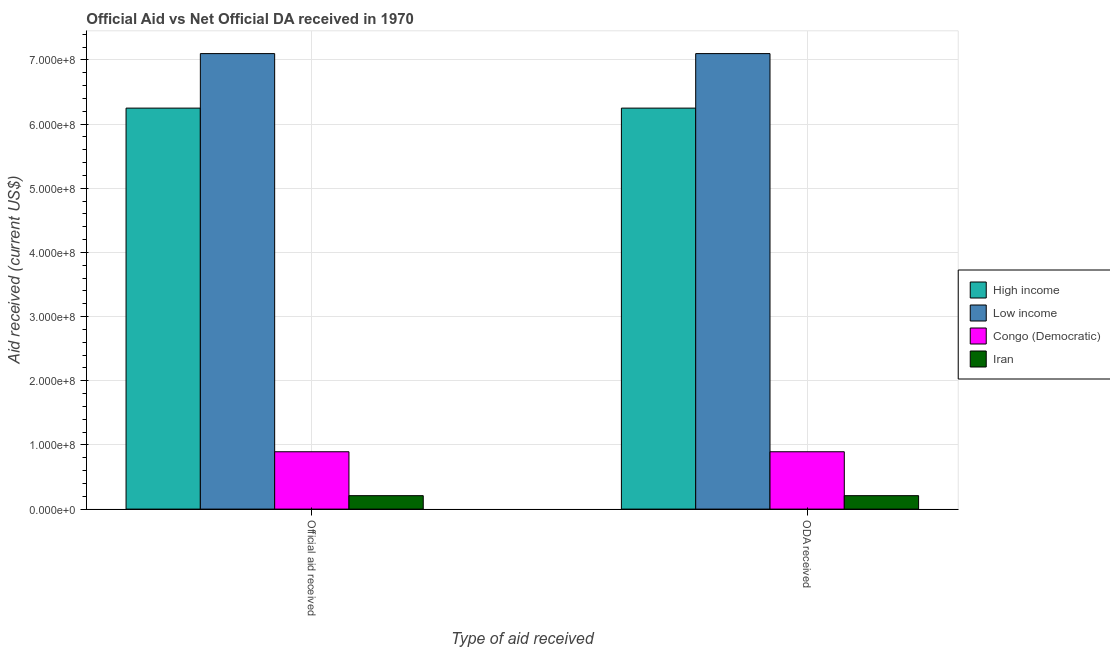How many groups of bars are there?
Keep it short and to the point. 2. How many bars are there on the 2nd tick from the left?
Give a very brief answer. 4. How many bars are there on the 1st tick from the right?
Provide a short and direct response. 4. What is the label of the 1st group of bars from the left?
Make the answer very short. Official aid received. What is the official aid received in Low income?
Make the answer very short. 7.10e+08. Across all countries, what is the maximum oda received?
Ensure brevity in your answer.  7.10e+08. Across all countries, what is the minimum oda received?
Give a very brief answer. 2.10e+07. In which country was the official aid received minimum?
Offer a very short reply. Iran. What is the total oda received in the graph?
Provide a short and direct response. 1.44e+09. What is the difference between the oda received in Iran and that in Low income?
Offer a very short reply. -6.89e+08. What is the difference between the official aid received in Congo (Democratic) and the oda received in Iran?
Your response must be concise. 6.84e+07. What is the average official aid received per country?
Provide a succinct answer. 3.61e+08. What is the difference between the oda received and official aid received in Low income?
Keep it short and to the point. 0. What is the ratio of the official aid received in Iran to that in High income?
Provide a short and direct response. 0.03. What does the 1st bar from the right in Official aid received represents?
Make the answer very short. Iran. Are the values on the major ticks of Y-axis written in scientific E-notation?
Offer a terse response. Yes. Where does the legend appear in the graph?
Offer a very short reply. Center right. How are the legend labels stacked?
Make the answer very short. Vertical. What is the title of the graph?
Give a very brief answer. Official Aid vs Net Official DA received in 1970 . Does "Macedonia" appear as one of the legend labels in the graph?
Ensure brevity in your answer.  No. What is the label or title of the X-axis?
Your answer should be compact. Type of aid received. What is the label or title of the Y-axis?
Offer a terse response. Aid received (current US$). What is the Aid received (current US$) of High income in Official aid received?
Ensure brevity in your answer.  6.25e+08. What is the Aid received (current US$) of Low income in Official aid received?
Your answer should be compact. 7.10e+08. What is the Aid received (current US$) in Congo (Democratic) in Official aid received?
Make the answer very short. 8.94e+07. What is the Aid received (current US$) of Iran in Official aid received?
Offer a very short reply. 2.10e+07. What is the Aid received (current US$) of High income in ODA received?
Offer a terse response. 6.25e+08. What is the Aid received (current US$) of Low income in ODA received?
Your answer should be compact. 7.10e+08. What is the Aid received (current US$) in Congo (Democratic) in ODA received?
Keep it short and to the point. 8.94e+07. What is the Aid received (current US$) in Iran in ODA received?
Ensure brevity in your answer.  2.10e+07. Across all Type of aid received, what is the maximum Aid received (current US$) of High income?
Provide a succinct answer. 6.25e+08. Across all Type of aid received, what is the maximum Aid received (current US$) of Low income?
Your answer should be very brief. 7.10e+08. Across all Type of aid received, what is the maximum Aid received (current US$) in Congo (Democratic)?
Offer a terse response. 8.94e+07. Across all Type of aid received, what is the maximum Aid received (current US$) of Iran?
Provide a succinct answer. 2.10e+07. Across all Type of aid received, what is the minimum Aid received (current US$) in High income?
Keep it short and to the point. 6.25e+08. Across all Type of aid received, what is the minimum Aid received (current US$) of Low income?
Keep it short and to the point. 7.10e+08. Across all Type of aid received, what is the minimum Aid received (current US$) in Congo (Democratic)?
Give a very brief answer. 8.94e+07. Across all Type of aid received, what is the minimum Aid received (current US$) in Iran?
Provide a short and direct response. 2.10e+07. What is the total Aid received (current US$) of High income in the graph?
Keep it short and to the point. 1.25e+09. What is the total Aid received (current US$) of Low income in the graph?
Offer a terse response. 1.42e+09. What is the total Aid received (current US$) in Congo (Democratic) in the graph?
Provide a short and direct response. 1.79e+08. What is the total Aid received (current US$) of Iran in the graph?
Ensure brevity in your answer.  4.19e+07. What is the difference between the Aid received (current US$) of High income in Official aid received and that in ODA received?
Offer a terse response. 0. What is the difference between the Aid received (current US$) in Low income in Official aid received and that in ODA received?
Make the answer very short. 0. What is the difference between the Aid received (current US$) in Congo (Democratic) in Official aid received and that in ODA received?
Your answer should be very brief. 0. What is the difference between the Aid received (current US$) in Iran in Official aid received and that in ODA received?
Offer a very short reply. 0. What is the difference between the Aid received (current US$) of High income in Official aid received and the Aid received (current US$) of Low income in ODA received?
Your response must be concise. -8.49e+07. What is the difference between the Aid received (current US$) in High income in Official aid received and the Aid received (current US$) in Congo (Democratic) in ODA received?
Provide a succinct answer. 5.35e+08. What is the difference between the Aid received (current US$) in High income in Official aid received and the Aid received (current US$) in Iran in ODA received?
Provide a succinct answer. 6.04e+08. What is the difference between the Aid received (current US$) of Low income in Official aid received and the Aid received (current US$) of Congo (Democratic) in ODA received?
Offer a terse response. 6.20e+08. What is the difference between the Aid received (current US$) in Low income in Official aid received and the Aid received (current US$) in Iran in ODA received?
Offer a terse response. 6.89e+08. What is the difference between the Aid received (current US$) of Congo (Democratic) in Official aid received and the Aid received (current US$) of Iran in ODA received?
Make the answer very short. 6.84e+07. What is the average Aid received (current US$) in High income per Type of aid received?
Your answer should be compact. 6.25e+08. What is the average Aid received (current US$) in Low income per Type of aid received?
Offer a very short reply. 7.10e+08. What is the average Aid received (current US$) in Congo (Democratic) per Type of aid received?
Make the answer very short. 8.94e+07. What is the average Aid received (current US$) in Iran per Type of aid received?
Keep it short and to the point. 2.10e+07. What is the difference between the Aid received (current US$) of High income and Aid received (current US$) of Low income in Official aid received?
Keep it short and to the point. -8.49e+07. What is the difference between the Aid received (current US$) of High income and Aid received (current US$) of Congo (Democratic) in Official aid received?
Your answer should be very brief. 5.35e+08. What is the difference between the Aid received (current US$) of High income and Aid received (current US$) of Iran in Official aid received?
Give a very brief answer. 6.04e+08. What is the difference between the Aid received (current US$) of Low income and Aid received (current US$) of Congo (Democratic) in Official aid received?
Provide a short and direct response. 6.20e+08. What is the difference between the Aid received (current US$) in Low income and Aid received (current US$) in Iran in Official aid received?
Offer a very short reply. 6.89e+08. What is the difference between the Aid received (current US$) of Congo (Democratic) and Aid received (current US$) of Iran in Official aid received?
Provide a succinct answer. 6.84e+07. What is the difference between the Aid received (current US$) in High income and Aid received (current US$) in Low income in ODA received?
Keep it short and to the point. -8.49e+07. What is the difference between the Aid received (current US$) in High income and Aid received (current US$) in Congo (Democratic) in ODA received?
Your response must be concise. 5.35e+08. What is the difference between the Aid received (current US$) in High income and Aid received (current US$) in Iran in ODA received?
Your answer should be very brief. 6.04e+08. What is the difference between the Aid received (current US$) of Low income and Aid received (current US$) of Congo (Democratic) in ODA received?
Provide a short and direct response. 6.20e+08. What is the difference between the Aid received (current US$) of Low income and Aid received (current US$) of Iran in ODA received?
Offer a very short reply. 6.89e+08. What is the difference between the Aid received (current US$) of Congo (Democratic) and Aid received (current US$) of Iran in ODA received?
Keep it short and to the point. 6.84e+07. What is the ratio of the Aid received (current US$) of Low income in Official aid received to that in ODA received?
Your answer should be very brief. 1. What is the ratio of the Aid received (current US$) of Congo (Democratic) in Official aid received to that in ODA received?
Provide a succinct answer. 1. What is the ratio of the Aid received (current US$) of Iran in Official aid received to that in ODA received?
Your answer should be very brief. 1. What is the difference between the highest and the second highest Aid received (current US$) in High income?
Give a very brief answer. 0. What is the difference between the highest and the second highest Aid received (current US$) in Congo (Democratic)?
Provide a short and direct response. 0. What is the difference between the highest and the lowest Aid received (current US$) of High income?
Make the answer very short. 0. What is the difference between the highest and the lowest Aid received (current US$) in Low income?
Offer a terse response. 0. What is the difference between the highest and the lowest Aid received (current US$) of Congo (Democratic)?
Provide a short and direct response. 0. What is the difference between the highest and the lowest Aid received (current US$) of Iran?
Offer a very short reply. 0. 